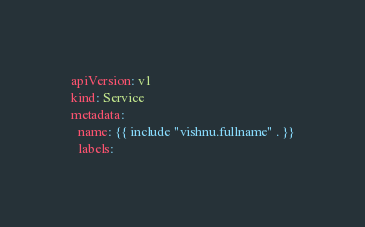<code> <loc_0><loc_0><loc_500><loc_500><_YAML_>apiVersion: v1
kind: Service
metadata:
  name: {{ include "vishnu.fullname" . }}
  labels:</code> 